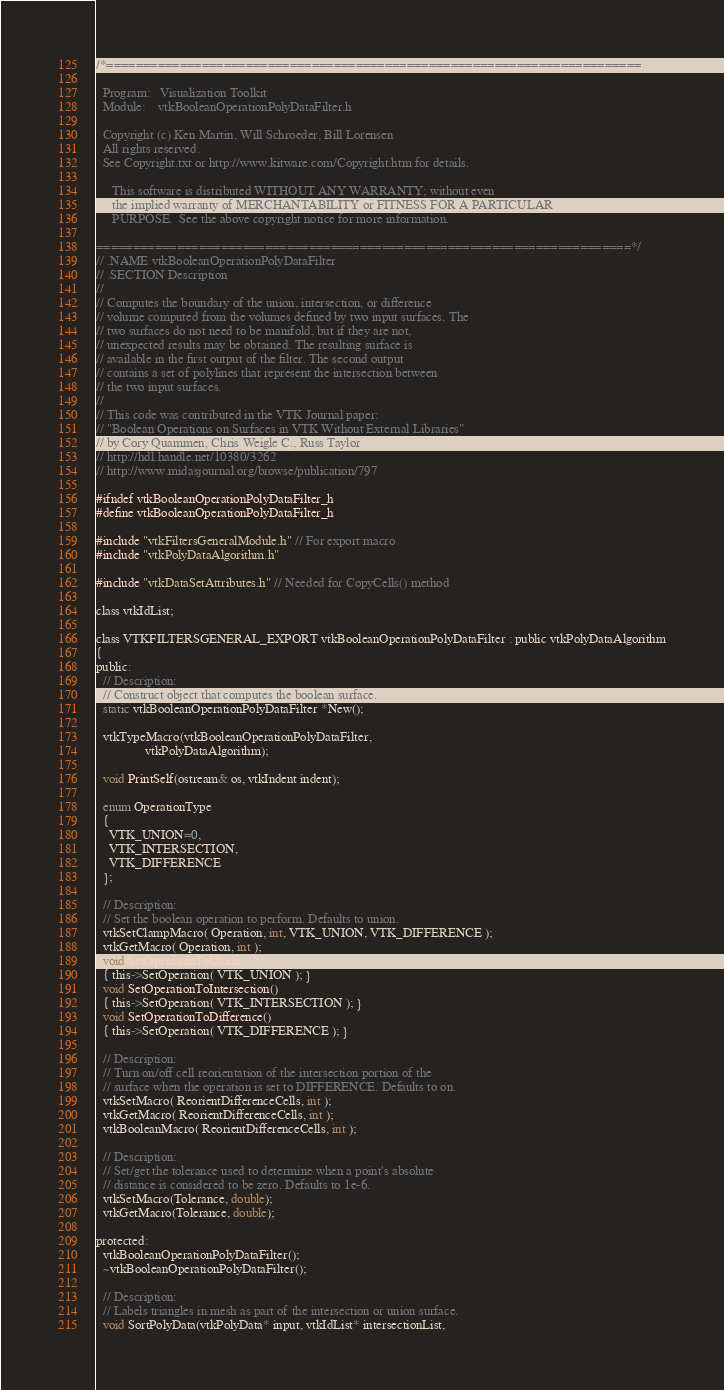Convert code to text. <code><loc_0><loc_0><loc_500><loc_500><_C_>/*=========================================================================

  Program:   Visualization Toolkit
  Module:    vtkBooleanOperationPolyDataFilter.h

  Copyright (c) Ken Martin, Will Schroeder, Bill Lorensen
  All rights reserved.
  See Copyright.txt or http://www.kitware.com/Copyright.htm for details.

     This software is distributed WITHOUT ANY WARRANTY; without even
     the implied warranty of MERCHANTABILITY or FITNESS FOR A PARTICULAR
     PURPOSE.  See the above copyright notice for more information.

=========================================================================*/
// .NAME vtkBooleanOperationPolyDataFilter
// .SECTION Description
//
// Computes the boundary of the union, intersection, or difference
// volume computed from the volumes defined by two input surfaces. The
// two surfaces do not need to be manifold, but if they are not,
// unexpected results may be obtained. The resulting surface is
// available in the first output of the filter. The second output
// contains a set of polylines that represent the intersection between
// the two input surfaces.
//
// This code was contributed in the VTK Journal paper:
// "Boolean Operations on Surfaces in VTK Without External Libraries"
// by Cory Quammen, Chris Weigle C., Russ Taylor
// http://hdl.handle.net/10380/3262
// http://www.midasjournal.org/browse/publication/797

#ifndef vtkBooleanOperationPolyDataFilter_h
#define vtkBooleanOperationPolyDataFilter_h

#include "vtkFiltersGeneralModule.h" // For export macro
#include "vtkPolyDataAlgorithm.h"

#include "vtkDataSetAttributes.h" // Needed for CopyCells() method

class vtkIdList;

class VTKFILTERSGENERAL_EXPORT vtkBooleanOperationPolyDataFilter : public vtkPolyDataAlgorithm
{
public:
  // Description:
  // Construct object that computes the boolean surface.
  static vtkBooleanOperationPolyDataFilter *New();

  vtkTypeMacro(vtkBooleanOperationPolyDataFilter,
               vtkPolyDataAlgorithm);

  void PrintSelf(ostream& os, vtkIndent indent);

  enum OperationType
  {
    VTK_UNION=0,
    VTK_INTERSECTION,
    VTK_DIFFERENCE
  };

  // Description:
  // Set the boolean operation to perform. Defaults to union.
  vtkSetClampMacro( Operation, int, VTK_UNION, VTK_DIFFERENCE );
  vtkGetMacro( Operation, int );
  void SetOperationToUnion()
  { this->SetOperation( VTK_UNION ); }
  void SetOperationToIntersection()
  { this->SetOperation( VTK_INTERSECTION ); }
  void SetOperationToDifference()
  { this->SetOperation( VTK_DIFFERENCE ); }

  // Description:
  // Turn on/off cell reorientation of the intersection portion of the
  // surface when the operation is set to DIFFERENCE. Defaults to on.
  vtkSetMacro( ReorientDifferenceCells, int );
  vtkGetMacro( ReorientDifferenceCells, int );
  vtkBooleanMacro( ReorientDifferenceCells, int );

  // Description:
  // Set/get the tolerance used to determine when a point's absolute
  // distance is considered to be zero. Defaults to 1e-6.
  vtkSetMacro(Tolerance, double);
  vtkGetMacro(Tolerance, double);

protected:
  vtkBooleanOperationPolyDataFilter();
  ~vtkBooleanOperationPolyDataFilter();

  // Description:
  // Labels triangles in mesh as part of the intersection or union surface.
  void SortPolyData(vtkPolyData* input, vtkIdList* intersectionList,</code> 